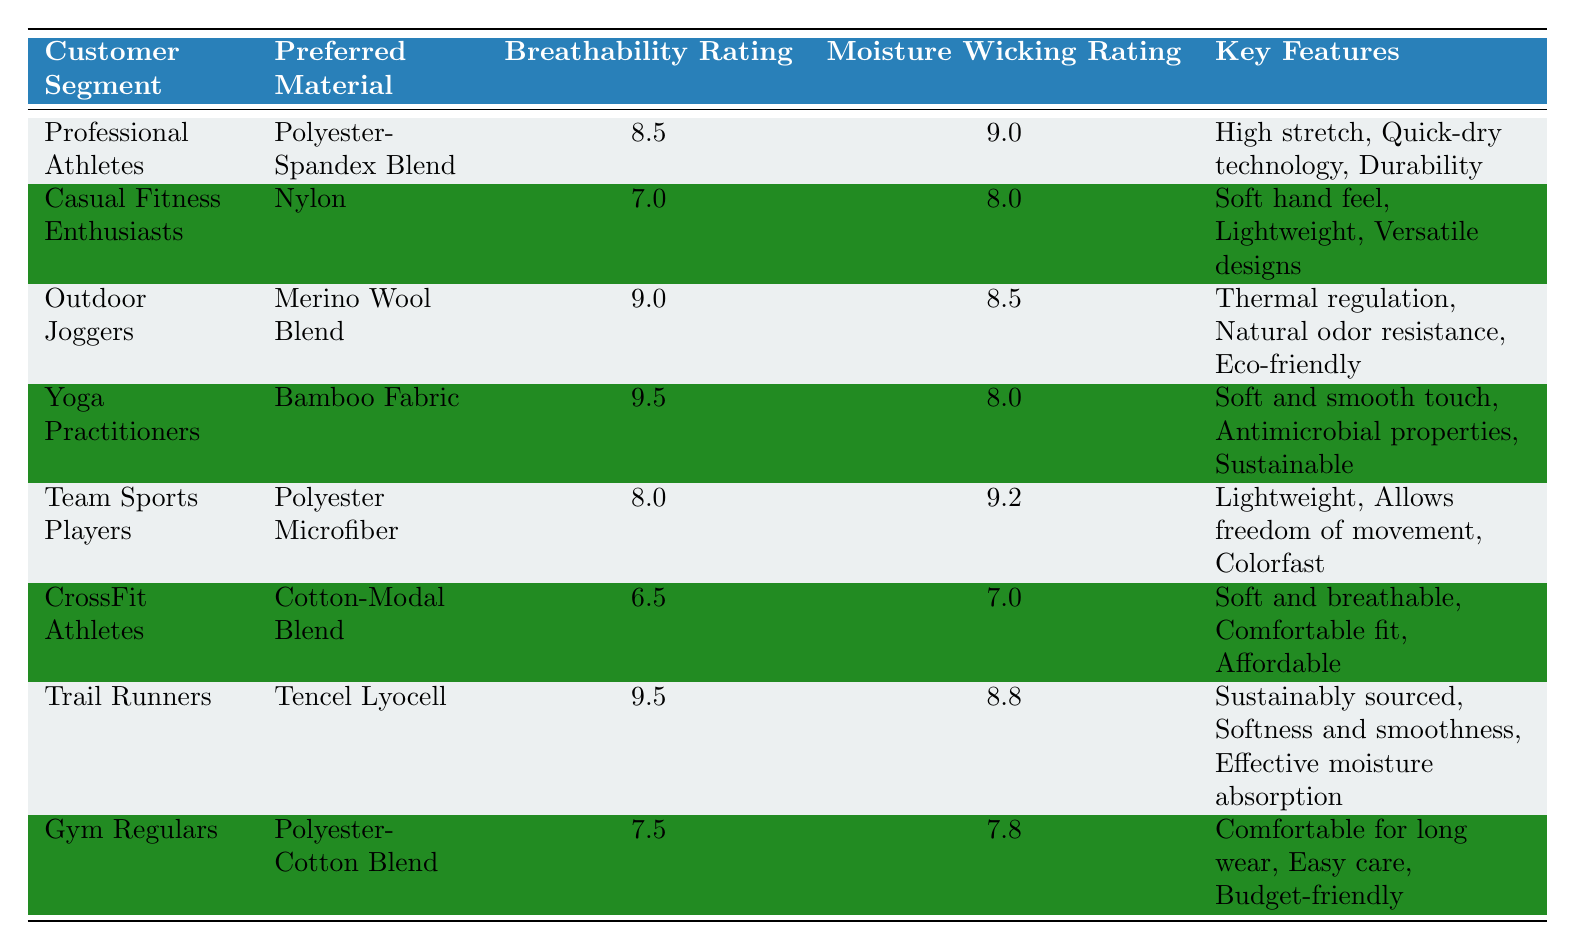What is the preferred material for Professional Athletes? The table indicates that Professional Athletes prefer a Polyester-Spandex Blend as their material of choice.
Answer: Polyester-Spandex Blend Which customer segment has the highest breathability rating? By scanning the breathability ratings in the table, both Yoga Practitioners and Trail Runners have the highest rating of 9.5.
Answer: Yoga Practitioners and Trail Runners What is the moisture-wicking rating of CrossFit Athletes? The table shows that CrossFit Athletes have a moisture-wicking rating of 7.0.
Answer: 7.0 Is the preferred material for Team Sports Players lightweight? The table states that Team Sports Players prefer a Polyester Microfiber material, which is described as lightweight. Therefore, the answer is yes.
Answer: Yes What is the average moisture-wicking rating for all customer segments? First, sum the moisture-wicking ratings: (9.0 + 8.0 + 8.5 + 8.0 + 9.2 + 7.0 + 8.8 + 7.8) = 66.5. There are 8 customer segments, so average = 66.5 / 8 = 8.3125.
Answer: 8.31 Which customer segment has the lowest breathability rating? Reviewing the breathability ratings, CrossFit Athletes have the lowest rating at 6.5.
Answer: CrossFit Athletes What are the key features of the preferred material for Casual Fitness Enthusiasts? According to the table, the key features for Casual Fitness Enthusiasts, who prefer Nylon, include soft hand feel, lightweight, and versatile designs.
Answer: Soft hand feel, lightweight, versatile designs Do Trial Runners prefer a moisture-wicking rating above 8? The moisture-wicking rating for Trail Runners is 8.8, which is above 8, making the answer yes.
Answer: Yes Which material is preferred by Yoga Practitioners? The table states that Yoga Practitioners prefer Bamboo Fabric as their material of choice.
Answer: Bamboo Fabric 